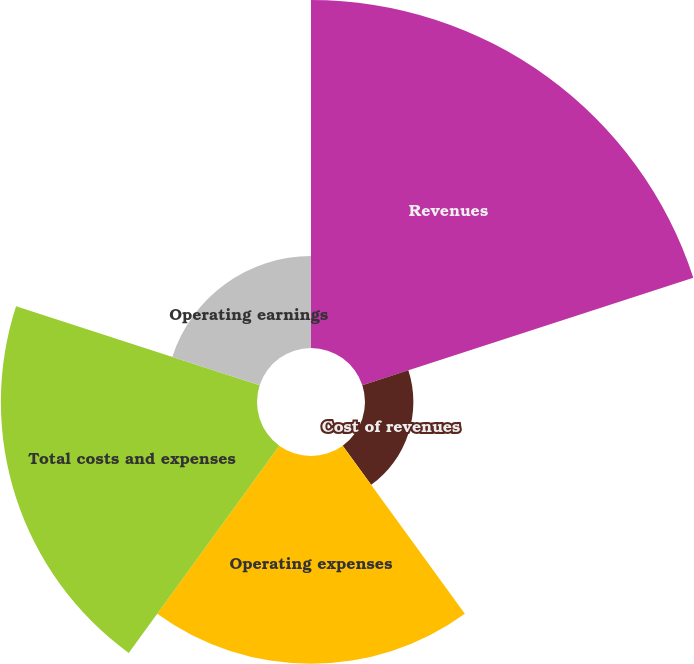Convert chart. <chart><loc_0><loc_0><loc_500><loc_500><pie_chart><fcel>Revenues<fcel>Cost of revenues<fcel>Operating expenses<fcel>Total costs and expenses<fcel>Operating earnings<nl><fcel>36.55%<fcel>5.08%<fcel>21.82%<fcel>26.9%<fcel>9.65%<nl></chart> 